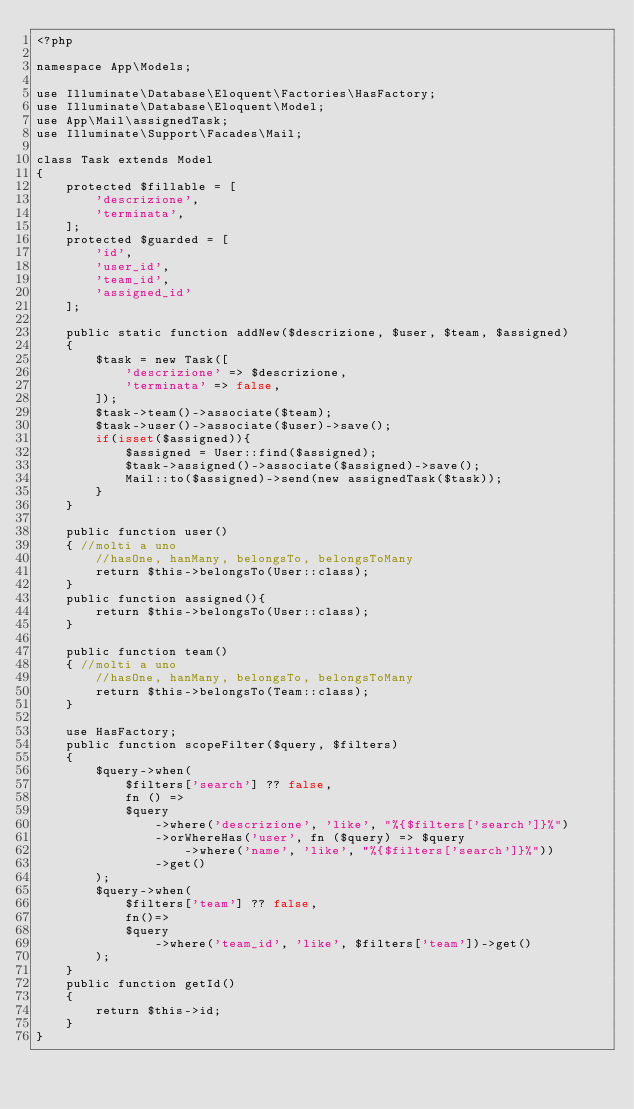<code> <loc_0><loc_0><loc_500><loc_500><_PHP_><?php

namespace App\Models;

use Illuminate\Database\Eloquent\Factories\HasFactory;
use Illuminate\Database\Eloquent\Model;
use App\Mail\assignedTask;
use Illuminate\Support\Facades\Mail;

class Task extends Model
{
    protected $fillable = [
        'descrizione',
        'terminata',
    ];
    protected $guarded = [
        'id',
        'user_id',
        'team_id',
        'assigned_id'
    ];

    public static function addNew($descrizione, $user, $team, $assigned)
    {
        $task = new Task([
            'descrizione' => $descrizione,
            'terminata' => false,
        ]);
        $task->team()->associate($team);
        $task->user()->associate($user)->save();
        if(isset($assigned)){
            $assigned = User::find($assigned);
            $task->assigned()->associate($assigned)->save();
            Mail::to($assigned)->send(new assignedTask($task));
        }
    }

    public function user()
    { //molti a uno
        //hasOne, hanMany, belongsTo, belongsToMany
        return $this->belongsTo(User::class);
    }
    public function assigned(){
        return $this->belongsTo(User::class);
    }

    public function team()
    { //molti a uno
        //hasOne, hanMany, belongsTo, belongsToMany
        return $this->belongsTo(Team::class);
    }

    use HasFactory;
    public function scopeFilter($query, $filters)
    {
        $query->when(
            $filters['search'] ?? false,
            fn () =>
            $query
                ->where('descrizione', 'like', "%{$filters['search']}%")
                ->orWhereHas('user', fn ($query) => $query
                    ->where('name', 'like', "%{$filters['search']}%"))
                ->get()
        );
        $query->when(
            $filters['team'] ?? false,
            fn()=>
            $query
                ->where('team_id', 'like', $filters['team'])->get()
        );
    }
    public function getId()
    {
        return $this->id;
    }
}
</code> 